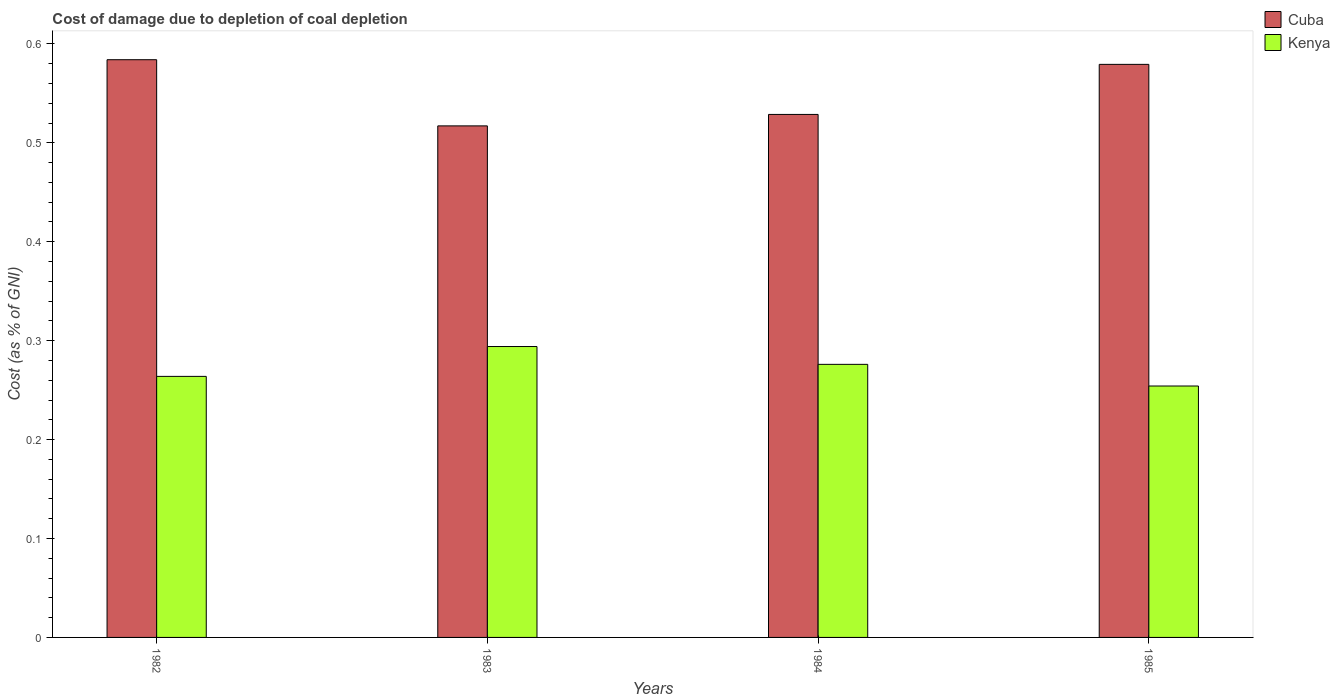How many different coloured bars are there?
Make the answer very short. 2. How many groups of bars are there?
Ensure brevity in your answer.  4. Are the number of bars per tick equal to the number of legend labels?
Make the answer very short. Yes. How many bars are there on the 3rd tick from the left?
Provide a short and direct response. 2. How many bars are there on the 3rd tick from the right?
Offer a terse response. 2. What is the cost of damage caused due to coal depletion in Cuba in 1982?
Keep it short and to the point. 0.58. Across all years, what is the maximum cost of damage caused due to coal depletion in Kenya?
Offer a terse response. 0.29. Across all years, what is the minimum cost of damage caused due to coal depletion in Cuba?
Offer a very short reply. 0.52. What is the total cost of damage caused due to coal depletion in Cuba in the graph?
Your answer should be compact. 2.21. What is the difference between the cost of damage caused due to coal depletion in Cuba in 1982 and that in 1984?
Make the answer very short. 0.06. What is the difference between the cost of damage caused due to coal depletion in Kenya in 1983 and the cost of damage caused due to coal depletion in Cuba in 1985?
Ensure brevity in your answer.  -0.29. What is the average cost of damage caused due to coal depletion in Kenya per year?
Provide a succinct answer. 0.27. In the year 1985, what is the difference between the cost of damage caused due to coal depletion in Cuba and cost of damage caused due to coal depletion in Kenya?
Provide a short and direct response. 0.33. In how many years, is the cost of damage caused due to coal depletion in Kenya greater than 0.54 %?
Your answer should be very brief. 0. What is the ratio of the cost of damage caused due to coal depletion in Kenya in 1983 to that in 1985?
Your response must be concise. 1.16. Is the cost of damage caused due to coal depletion in Kenya in 1982 less than that in 1983?
Offer a very short reply. Yes. Is the difference between the cost of damage caused due to coal depletion in Cuba in 1983 and 1984 greater than the difference between the cost of damage caused due to coal depletion in Kenya in 1983 and 1984?
Provide a succinct answer. No. What is the difference between the highest and the second highest cost of damage caused due to coal depletion in Kenya?
Give a very brief answer. 0.02. What is the difference between the highest and the lowest cost of damage caused due to coal depletion in Cuba?
Your answer should be very brief. 0.07. In how many years, is the cost of damage caused due to coal depletion in Cuba greater than the average cost of damage caused due to coal depletion in Cuba taken over all years?
Ensure brevity in your answer.  2. Is the sum of the cost of damage caused due to coal depletion in Cuba in 1982 and 1985 greater than the maximum cost of damage caused due to coal depletion in Kenya across all years?
Offer a very short reply. Yes. What does the 2nd bar from the left in 1984 represents?
Give a very brief answer. Kenya. What does the 1st bar from the right in 1983 represents?
Keep it short and to the point. Kenya. How many bars are there?
Make the answer very short. 8. Are all the bars in the graph horizontal?
Your answer should be very brief. No. How many years are there in the graph?
Provide a short and direct response. 4. Does the graph contain any zero values?
Make the answer very short. No. What is the title of the graph?
Your answer should be compact. Cost of damage due to depletion of coal depletion. Does "Germany" appear as one of the legend labels in the graph?
Give a very brief answer. No. What is the label or title of the Y-axis?
Give a very brief answer. Cost (as % of GNI). What is the Cost (as % of GNI) of Cuba in 1982?
Your response must be concise. 0.58. What is the Cost (as % of GNI) in Kenya in 1982?
Provide a succinct answer. 0.26. What is the Cost (as % of GNI) in Cuba in 1983?
Ensure brevity in your answer.  0.52. What is the Cost (as % of GNI) in Kenya in 1983?
Your response must be concise. 0.29. What is the Cost (as % of GNI) in Cuba in 1984?
Give a very brief answer. 0.53. What is the Cost (as % of GNI) of Kenya in 1984?
Provide a short and direct response. 0.28. What is the Cost (as % of GNI) of Cuba in 1985?
Keep it short and to the point. 0.58. What is the Cost (as % of GNI) of Kenya in 1985?
Your answer should be compact. 0.25. Across all years, what is the maximum Cost (as % of GNI) of Cuba?
Offer a terse response. 0.58. Across all years, what is the maximum Cost (as % of GNI) in Kenya?
Provide a succinct answer. 0.29. Across all years, what is the minimum Cost (as % of GNI) of Cuba?
Give a very brief answer. 0.52. Across all years, what is the minimum Cost (as % of GNI) in Kenya?
Offer a very short reply. 0.25. What is the total Cost (as % of GNI) of Cuba in the graph?
Offer a terse response. 2.21. What is the total Cost (as % of GNI) in Kenya in the graph?
Give a very brief answer. 1.09. What is the difference between the Cost (as % of GNI) in Cuba in 1982 and that in 1983?
Your answer should be compact. 0.07. What is the difference between the Cost (as % of GNI) in Kenya in 1982 and that in 1983?
Your response must be concise. -0.03. What is the difference between the Cost (as % of GNI) of Cuba in 1982 and that in 1984?
Provide a short and direct response. 0.06. What is the difference between the Cost (as % of GNI) of Kenya in 1982 and that in 1984?
Offer a very short reply. -0.01. What is the difference between the Cost (as % of GNI) in Cuba in 1982 and that in 1985?
Make the answer very short. 0. What is the difference between the Cost (as % of GNI) of Kenya in 1982 and that in 1985?
Give a very brief answer. 0.01. What is the difference between the Cost (as % of GNI) of Cuba in 1983 and that in 1984?
Keep it short and to the point. -0.01. What is the difference between the Cost (as % of GNI) in Kenya in 1983 and that in 1984?
Your answer should be compact. 0.02. What is the difference between the Cost (as % of GNI) of Cuba in 1983 and that in 1985?
Your answer should be compact. -0.06. What is the difference between the Cost (as % of GNI) in Kenya in 1983 and that in 1985?
Provide a short and direct response. 0.04. What is the difference between the Cost (as % of GNI) in Cuba in 1984 and that in 1985?
Offer a terse response. -0.05. What is the difference between the Cost (as % of GNI) in Kenya in 1984 and that in 1985?
Keep it short and to the point. 0.02. What is the difference between the Cost (as % of GNI) of Cuba in 1982 and the Cost (as % of GNI) of Kenya in 1983?
Provide a succinct answer. 0.29. What is the difference between the Cost (as % of GNI) of Cuba in 1982 and the Cost (as % of GNI) of Kenya in 1984?
Your response must be concise. 0.31. What is the difference between the Cost (as % of GNI) of Cuba in 1982 and the Cost (as % of GNI) of Kenya in 1985?
Your answer should be compact. 0.33. What is the difference between the Cost (as % of GNI) of Cuba in 1983 and the Cost (as % of GNI) of Kenya in 1984?
Provide a short and direct response. 0.24. What is the difference between the Cost (as % of GNI) in Cuba in 1983 and the Cost (as % of GNI) in Kenya in 1985?
Your answer should be very brief. 0.26. What is the difference between the Cost (as % of GNI) of Cuba in 1984 and the Cost (as % of GNI) of Kenya in 1985?
Your answer should be very brief. 0.27. What is the average Cost (as % of GNI) in Cuba per year?
Offer a very short reply. 0.55. What is the average Cost (as % of GNI) of Kenya per year?
Your answer should be compact. 0.27. In the year 1982, what is the difference between the Cost (as % of GNI) in Cuba and Cost (as % of GNI) in Kenya?
Offer a very short reply. 0.32. In the year 1983, what is the difference between the Cost (as % of GNI) of Cuba and Cost (as % of GNI) of Kenya?
Offer a terse response. 0.22. In the year 1984, what is the difference between the Cost (as % of GNI) of Cuba and Cost (as % of GNI) of Kenya?
Ensure brevity in your answer.  0.25. In the year 1985, what is the difference between the Cost (as % of GNI) in Cuba and Cost (as % of GNI) in Kenya?
Your answer should be compact. 0.33. What is the ratio of the Cost (as % of GNI) in Cuba in 1982 to that in 1983?
Provide a succinct answer. 1.13. What is the ratio of the Cost (as % of GNI) in Kenya in 1982 to that in 1983?
Your answer should be very brief. 0.9. What is the ratio of the Cost (as % of GNI) of Cuba in 1982 to that in 1984?
Provide a succinct answer. 1.1. What is the ratio of the Cost (as % of GNI) in Kenya in 1982 to that in 1984?
Provide a short and direct response. 0.96. What is the ratio of the Cost (as % of GNI) in Kenya in 1982 to that in 1985?
Offer a very short reply. 1.04. What is the ratio of the Cost (as % of GNI) of Cuba in 1983 to that in 1984?
Offer a very short reply. 0.98. What is the ratio of the Cost (as % of GNI) of Kenya in 1983 to that in 1984?
Ensure brevity in your answer.  1.07. What is the ratio of the Cost (as % of GNI) of Cuba in 1983 to that in 1985?
Offer a terse response. 0.89. What is the ratio of the Cost (as % of GNI) of Kenya in 1983 to that in 1985?
Provide a short and direct response. 1.16. What is the ratio of the Cost (as % of GNI) in Cuba in 1984 to that in 1985?
Keep it short and to the point. 0.91. What is the ratio of the Cost (as % of GNI) in Kenya in 1984 to that in 1985?
Offer a terse response. 1.09. What is the difference between the highest and the second highest Cost (as % of GNI) of Cuba?
Give a very brief answer. 0. What is the difference between the highest and the second highest Cost (as % of GNI) in Kenya?
Ensure brevity in your answer.  0.02. What is the difference between the highest and the lowest Cost (as % of GNI) of Cuba?
Offer a very short reply. 0.07. What is the difference between the highest and the lowest Cost (as % of GNI) in Kenya?
Offer a very short reply. 0.04. 